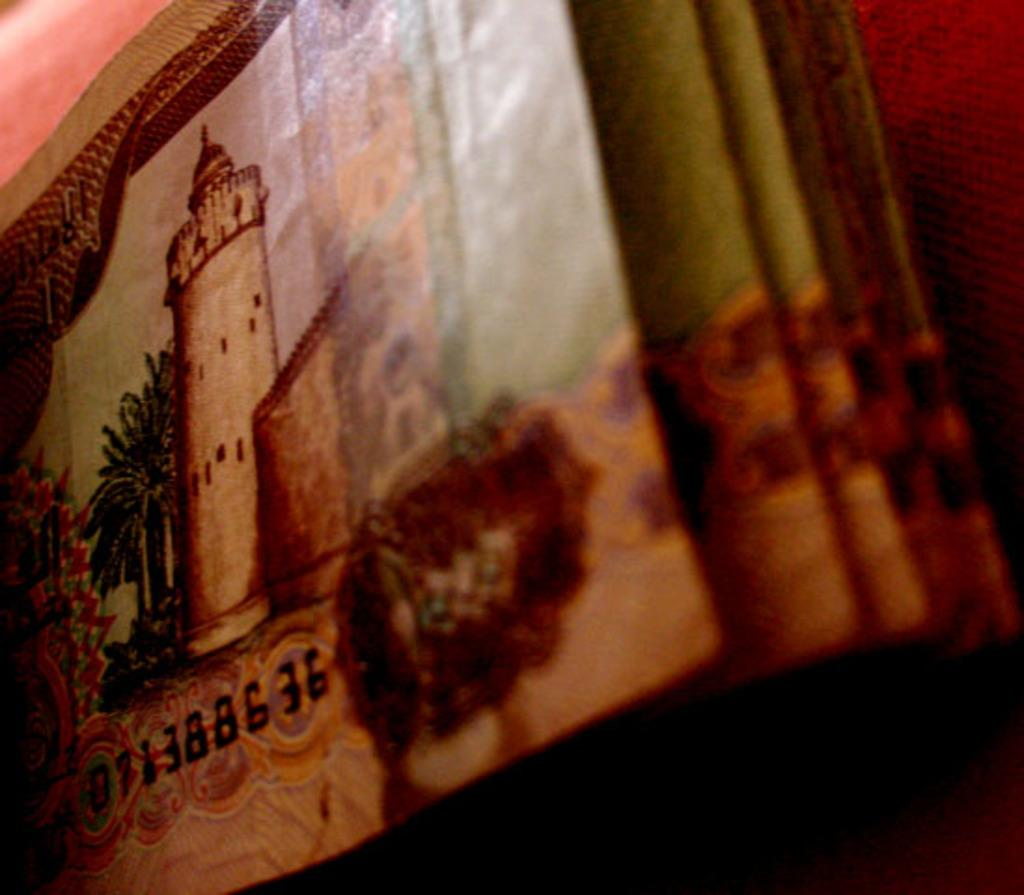<image>
Present a compact description of the photo's key features. A colorful object has a serial or id number ending in the digits 636. 